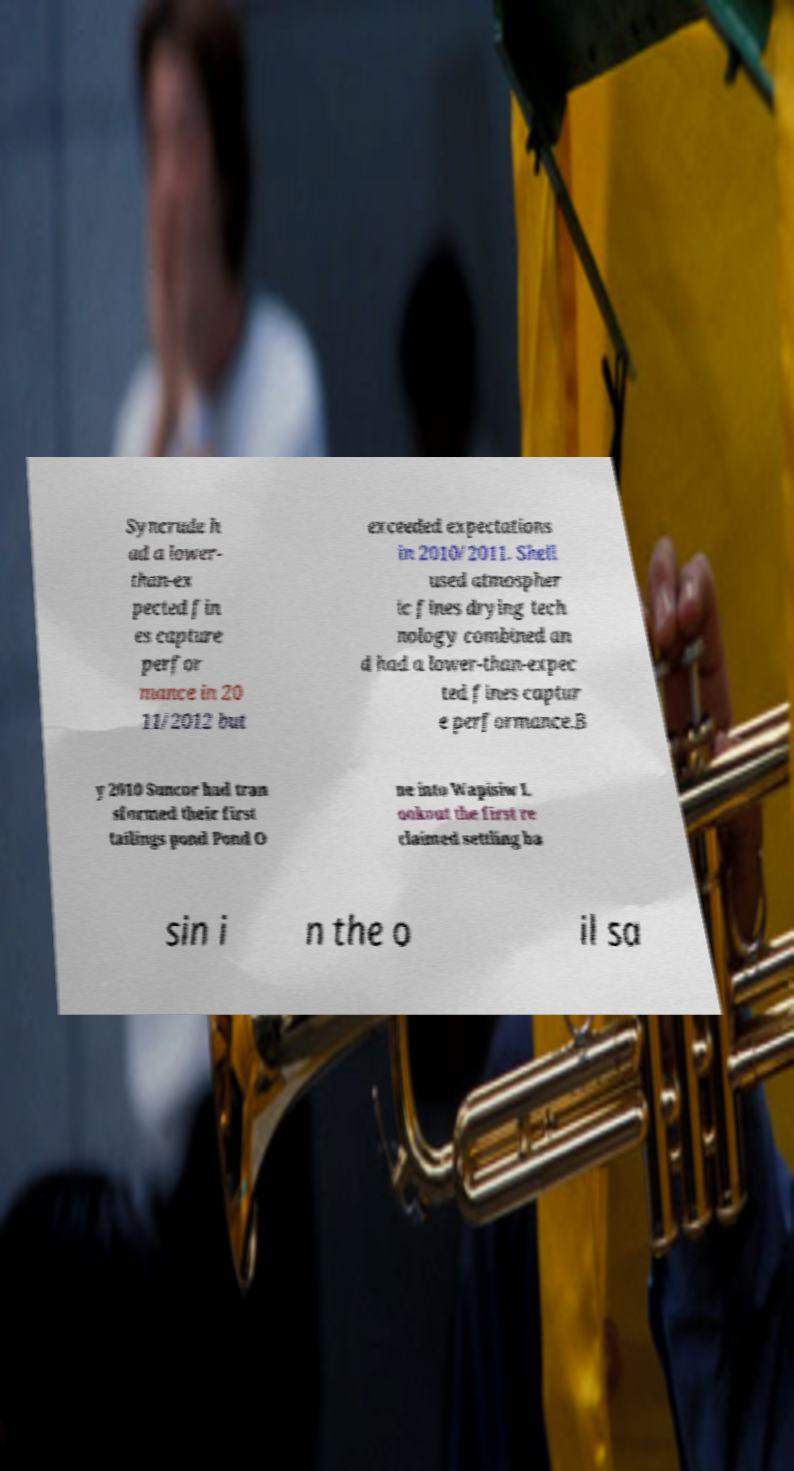What messages or text are displayed in this image? I need them in a readable, typed format. Syncrude h ad a lower- than-ex pected fin es capture perfor mance in 20 11/2012 but exceeded expectations in 2010/2011. Shell used atmospher ic fines drying tech nology combined an d had a lower-than-expec ted fines captur e performance.B y 2010 Suncor had tran sformed their first tailings pond Pond O ne into Wapisiw L ookout the first re claimed settling ba sin i n the o il sa 